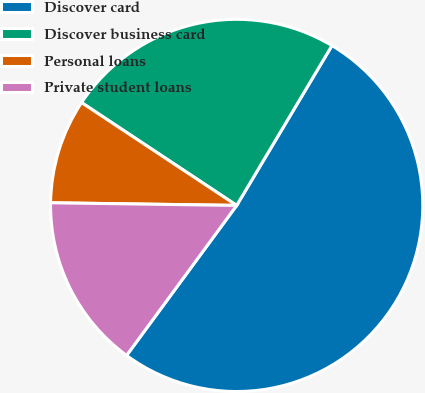Convert chart to OTSL. <chart><loc_0><loc_0><loc_500><loc_500><pie_chart><fcel>Discover card<fcel>Discover business card<fcel>Personal loans<fcel>Private student loans<nl><fcel>51.52%<fcel>24.24%<fcel>9.09%<fcel>15.15%<nl></chart> 